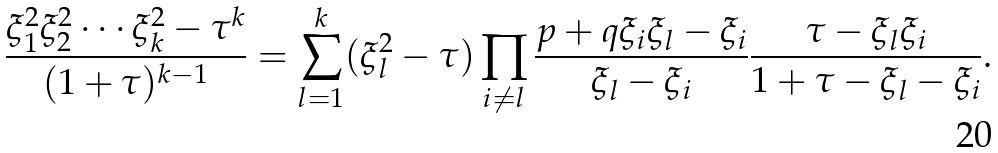<formula> <loc_0><loc_0><loc_500><loc_500>\frac { \xi _ { 1 } ^ { 2 } \xi _ { 2 } ^ { 2 } \cdots \xi _ { k } ^ { 2 } - \tau ^ { k } } { ( 1 + \tau ) ^ { k - 1 } } = \sum _ { l = 1 } ^ { k } ( \xi _ { l } ^ { 2 } - \tau ) \prod _ { i \neq l } \frac { p + q \xi _ { i } \xi _ { l } - \xi _ { i } } { \xi _ { l } - \xi _ { i } } \frac { \tau - \xi _ { l } \xi _ { i } } { 1 + \tau - \xi _ { l } - \xi _ { i } } .</formula> 